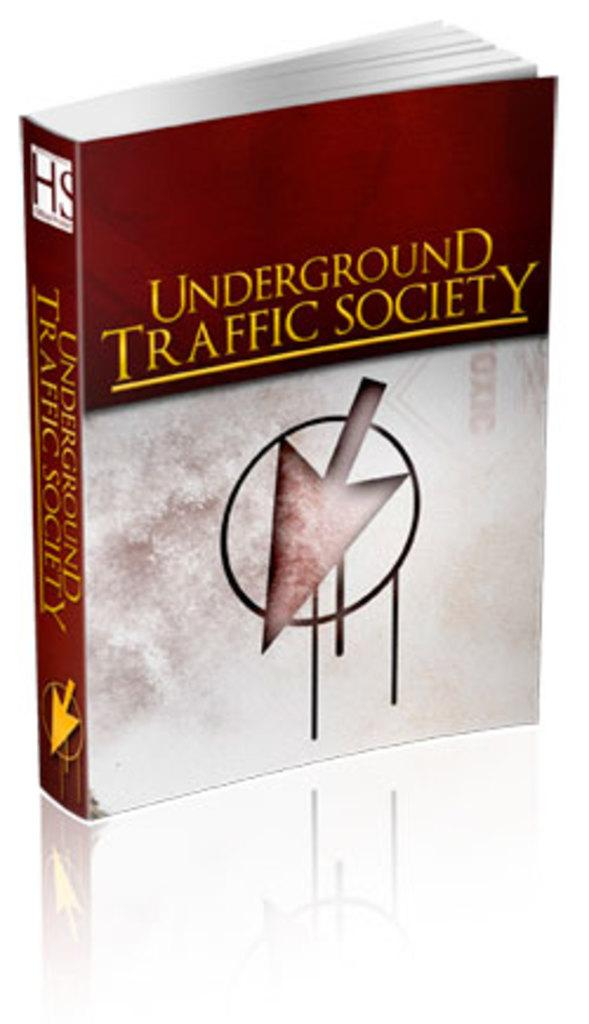<image>
Offer a succinct explanation of the picture presented. A book titled Underground Traffic Society has an arrow on it. 